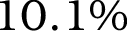<formula> <loc_0><loc_0><loc_500><loc_500>1 0 . 1 \%</formula> 